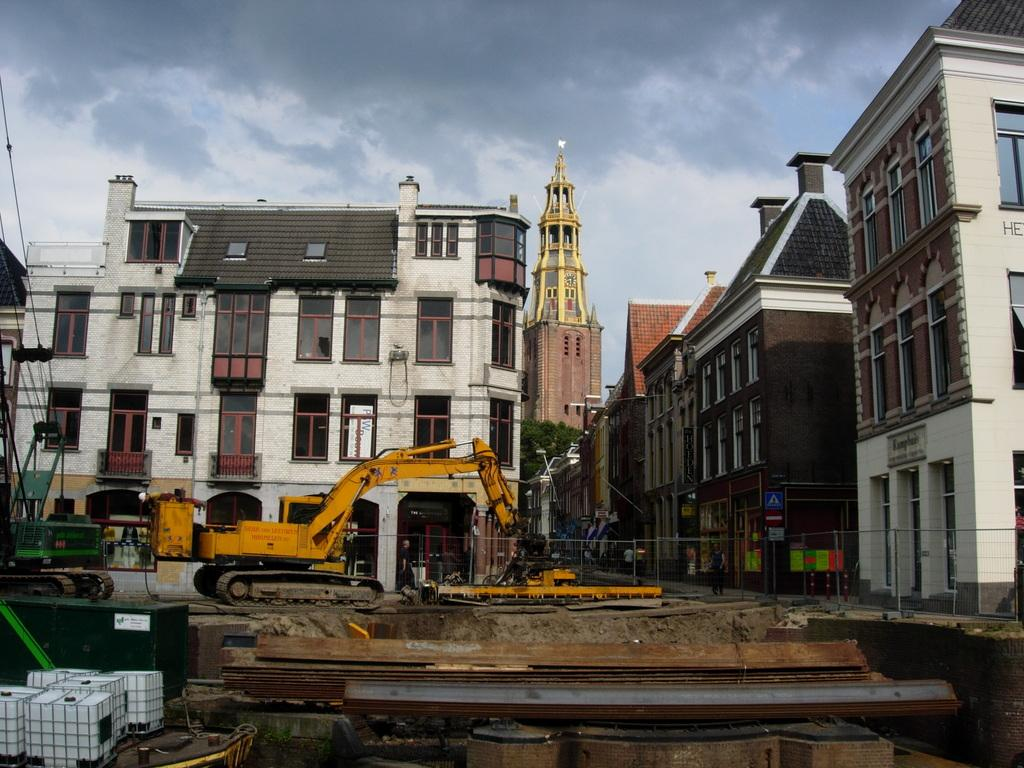What is the main subject in the center of the image? There is a proclainer in the center of the image. What can be seen in the background of the image? There are many buildings in the background of the image. What is visible at the top of the image? The sky is visible at the top of the image. What can be observed in the sky? Clouds are present in the sky. What type of lamp is hanging from the carriage in the image? There is no lamp or carriage present in the image; it features a proclainer and buildings in the background. 